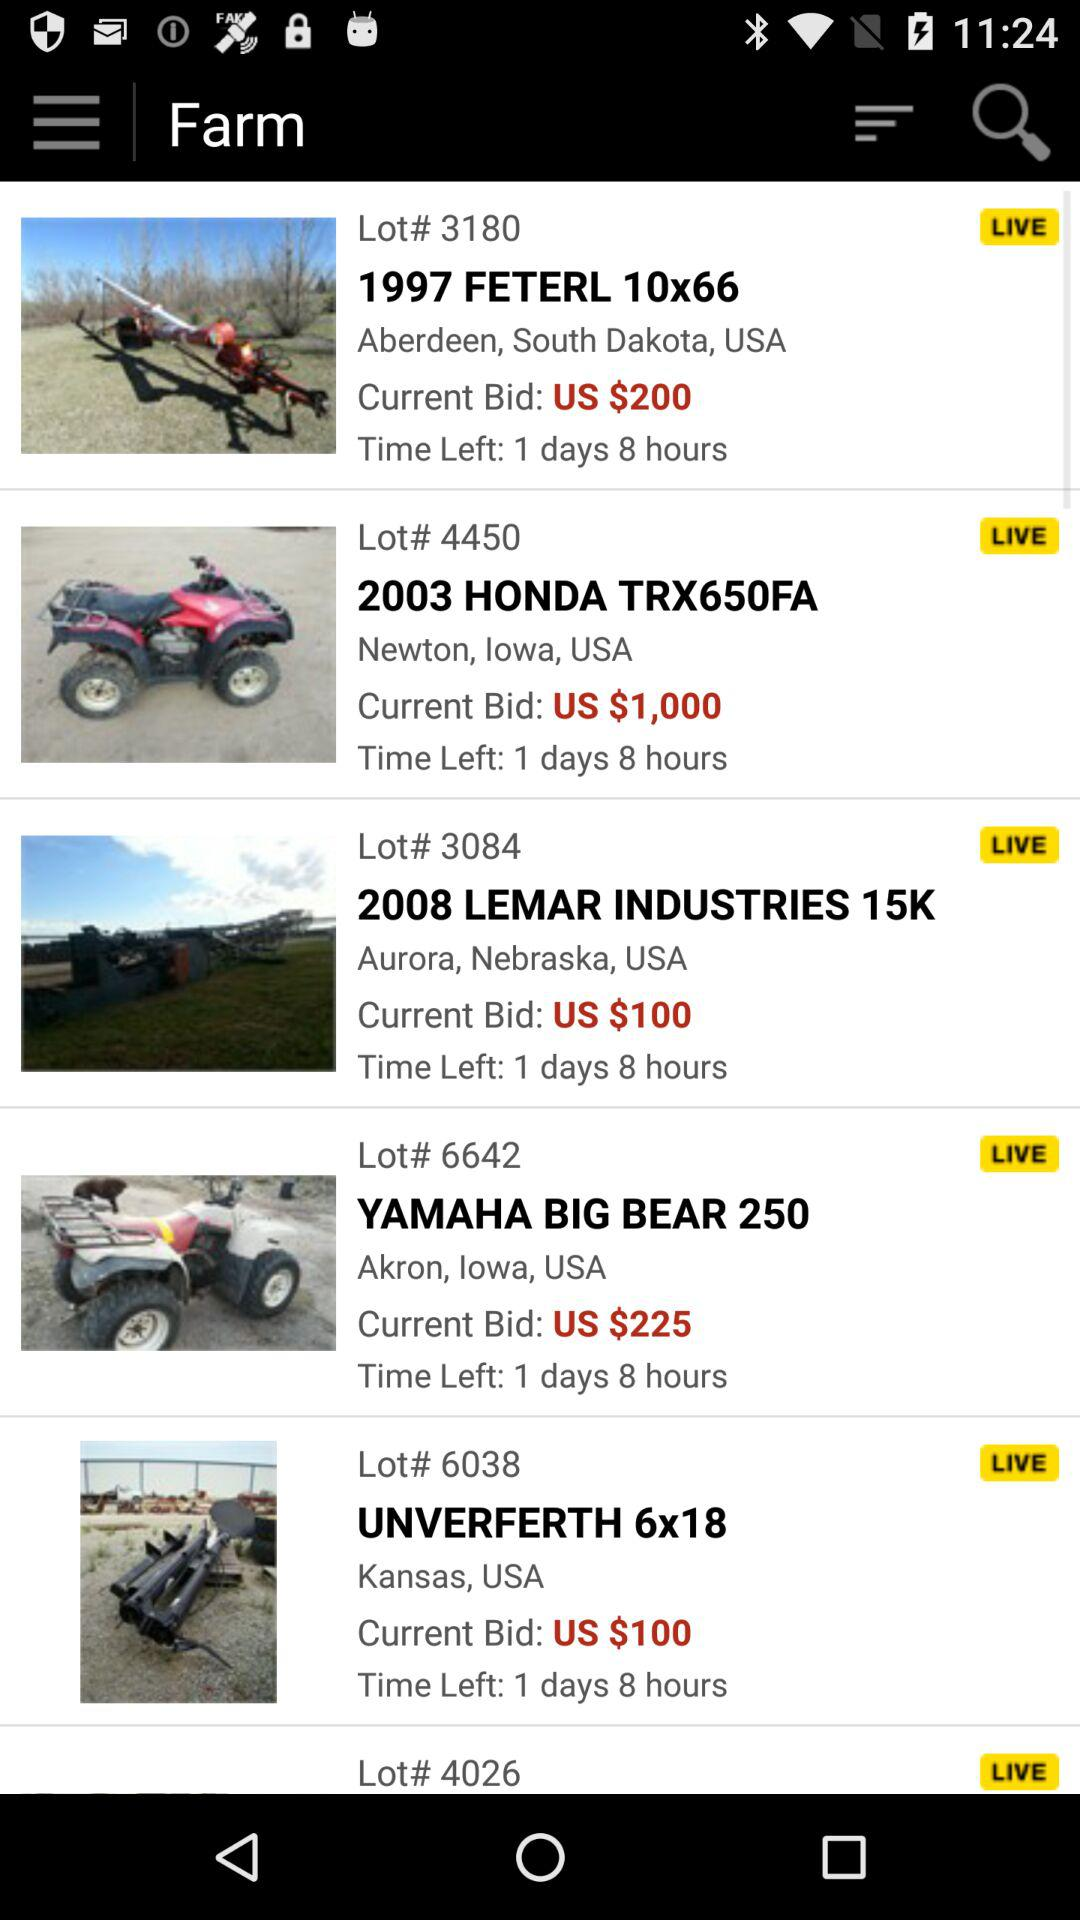How much time is left for "2003 HONDA TRX650FA" bid to end? The left time is 1 day and 8 hours. 